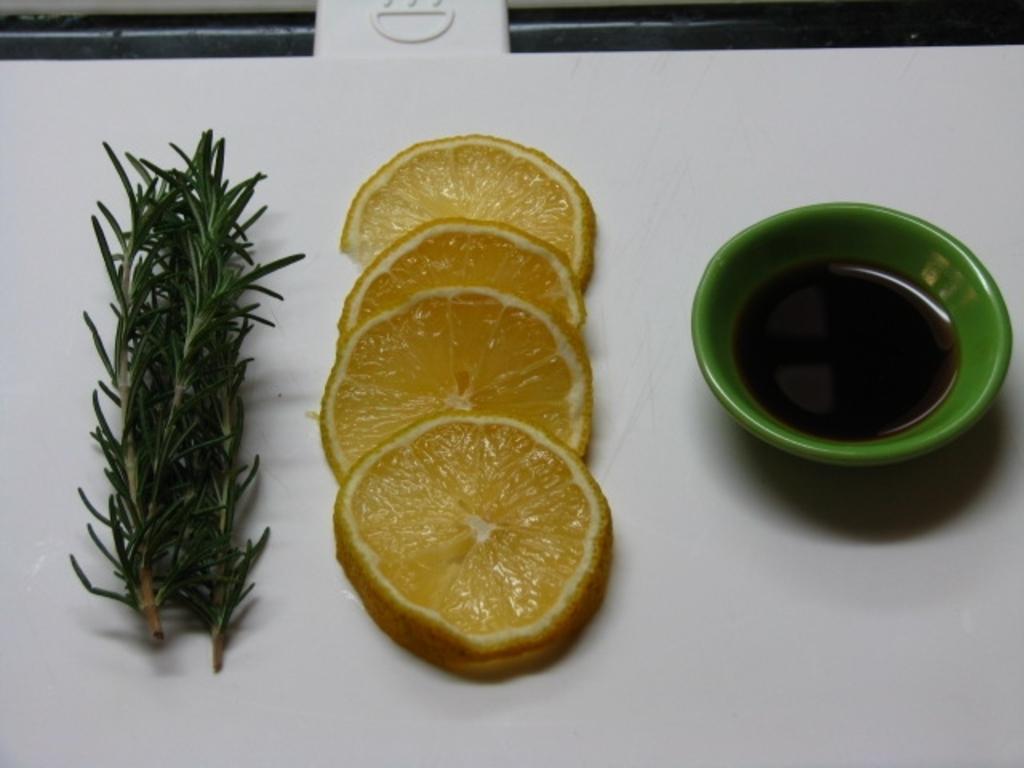Can you describe this image briefly? In this image there is a table, on the table there are lemon slices, a plant and some liquid in the cup. 